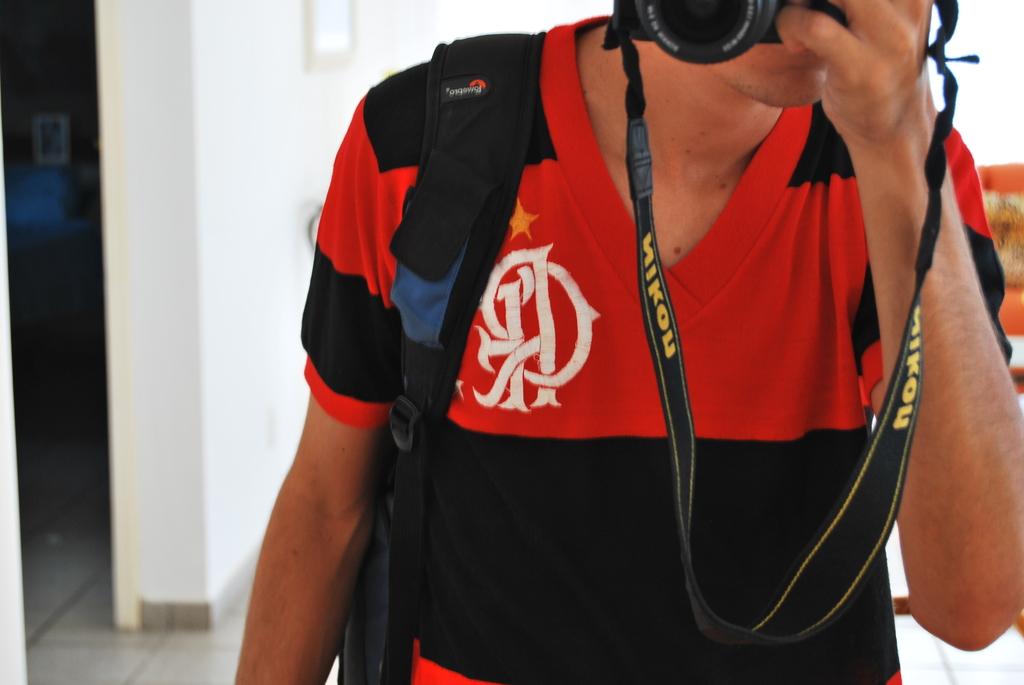Is that a nikon strap?
Make the answer very short. Yes. What brand of camera is shown on the camera strap?
Provide a short and direct response. Nikon. 